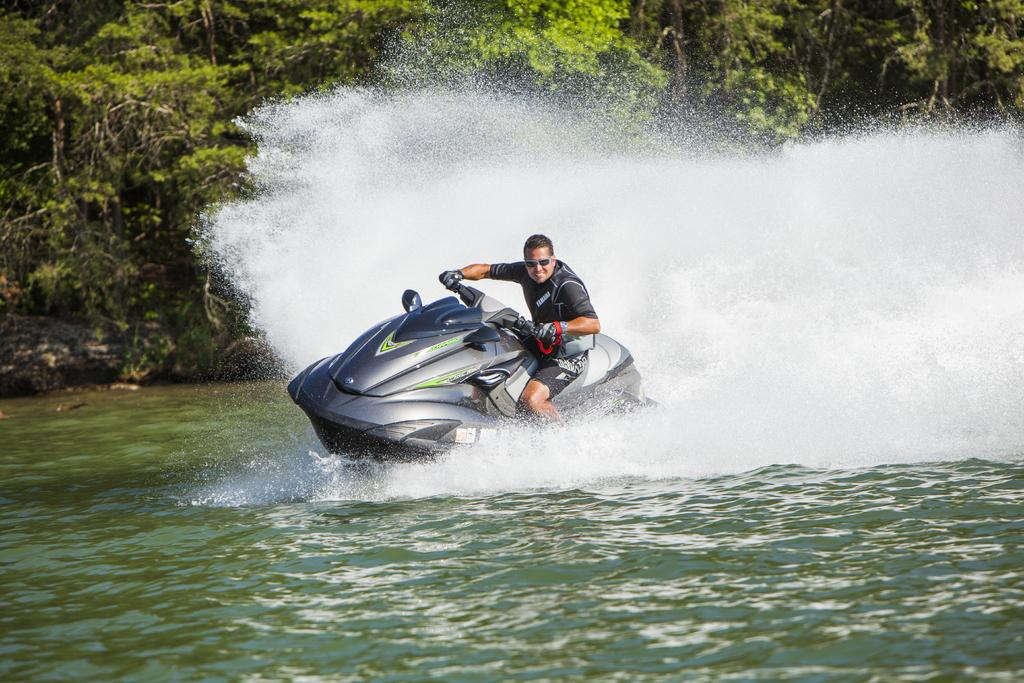What is the person in the image doing? There is a person sitting on a speed boat in the image. What color is the speed boat? The speed boat is in ash and black color. What is the surrounding environment like in the image? There is water visible in the image, and there are trees present. How does the kitten affect the speed of the speed boat in the image? There is no kitten present in the image, so it cannot affect the speed of the speed boat. 